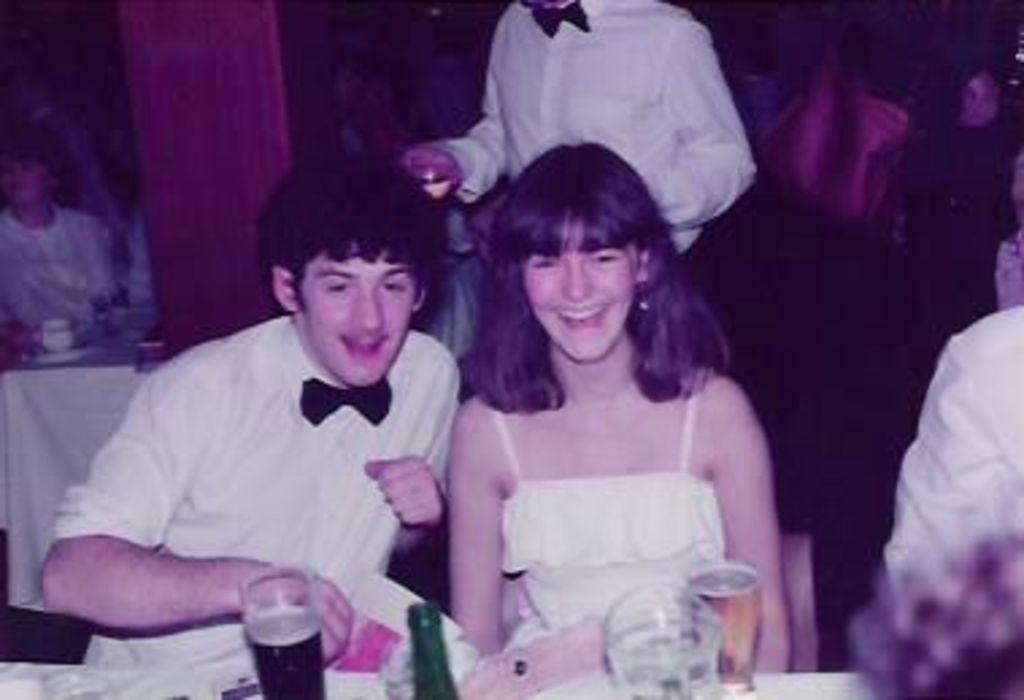Describe this image in one or two sentences. In this image there are some persons sitting in bottom of this image and there are some bottles and glasses are kept at bottom of this image. there are some persons standing at top of this image and there are some persons sitting at left side of this image. 